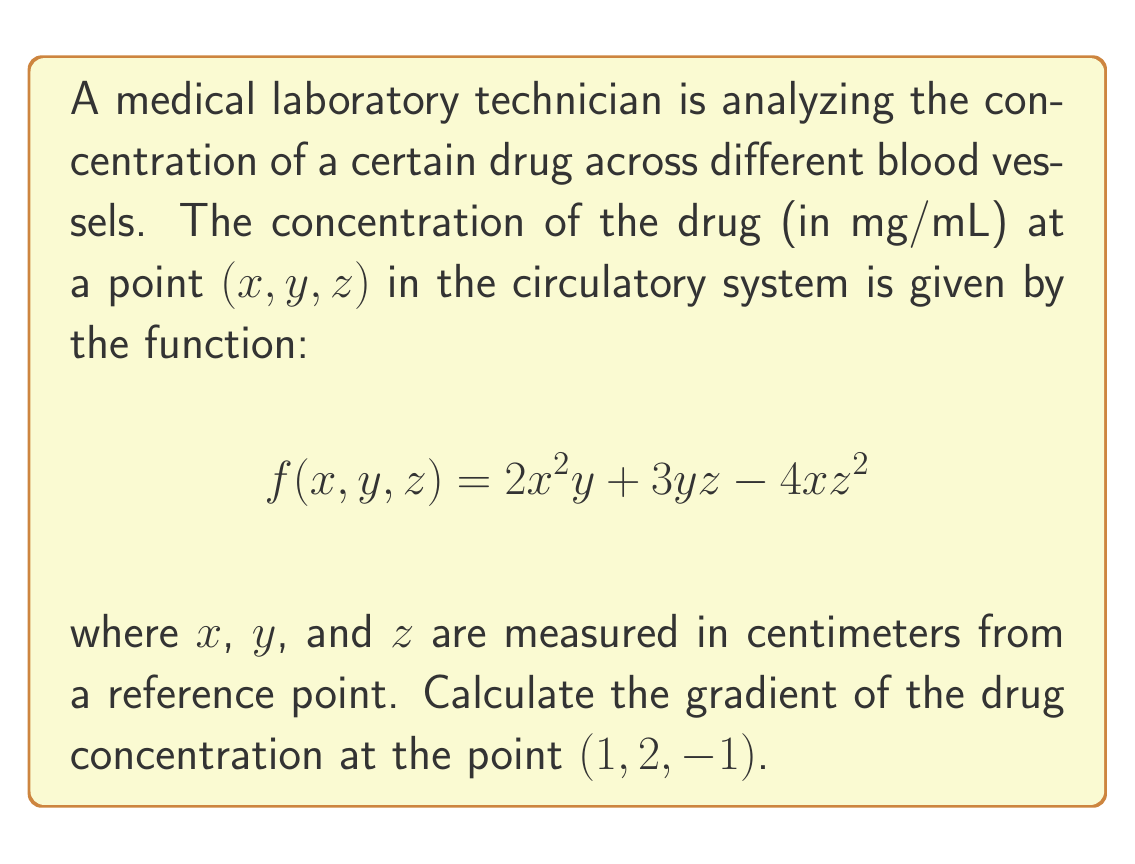Show me your answer to this math problem. To solve this problem, we need to calculate the gradient of the given function $f(x, y, z)$ at the point $(1, 2, -1)$. The gradient is a vector-valued function that consists of the partial derivatives of $f$ with respect to $x$, $y$, and $z$.

1) First, let's calculate the partial derivatives:

   $$\frac{\partial f}{\partial x} = 4xy - 4z^2$$
   $$\frac{\partial f}{\partial y} = 2x^2 + 3z$$
   $$\frac{\partial f}{\partial z} = 3y - 8xz$$

2) The gradient is defined as:

   $$\nabla f = \left(\frac{\partial f}{\partial x}, \frac{\partial f}{\partial y}, \frac{\partial f}{\partial z}\right)$$

3) Now, we need to evaluate each partial derivative at the point $(1, 2, -1)$:

   $$\frac{\partial f}{\partial x}(1, 2, -1) = 4(1)(2) - 4(-1)^2 = 8 - 4 = 4$$
   
   $$\frac{\partial f}{\partial y}(1, 2, -1) = 2(1)^2 + 3(-1) = 2 - 3 = -1$$
   
   $$\frac{\partial f}{\partial z}(1, 2, -1) = 3(2) - 8(1)(-1) = 6 + 8 = 14$$

4) Therefore, the gradient at the point $(1, 2, -1)$ is:

   $$\nabla f(1, 2, -1) = (4, -1, 14)$$

This gradient vector indicates the direction of steepest increase in drug concentration at the point $(1, 2, -1)$ in the circulatory system, and its magnitude represents the rate of change of concentration in that direction.
Answer: $$\nabla f(1, 2, -1) = (4, -1, 14)$$ 